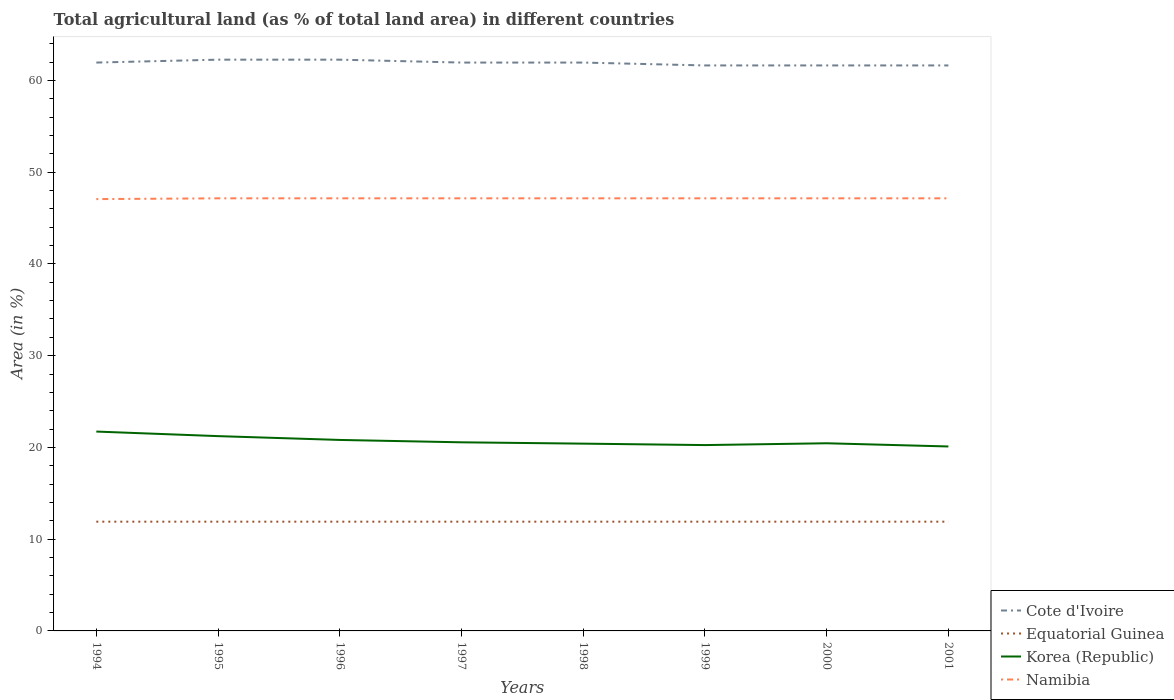How many different coloured lines are there?
Give a very brief answer. 4. Across all years, what is the maximum percentage of agricultural land in Equatorial Guinea?
Your answer should be very brief. 11.91. In which year was the percentage of agricultural land in Namibia maximum?
Keep it short and to the point. 1994. What is the total percentage of agricultural land in Korea (Republic) in the graph?
Give a very brief answer. 0.1. What is the difference between the highest and the second highest percentage of agricultural land in Cote d'Ivoire?
Your response must be concise. 0.63. What is the difference between the highest and the lowest percentage of agricultural land in Namibia?
Offer a very short reply. 7. How many years are there in the graph?
Your answer should be compact. 8. Are the values on the major ticks of Y-axis written in scientific E-notation?
Your answer should be very brief. No. Does the graph contain grids?
Ensure brevity in your answer.  No. Where does the legend appear in the graph?
Provide a succinct answer. Bottom right. How many legend labels are there?
Your answer should be very brief. 4. What is the title of the graph?
Keep it short and to the point. Total agricultural land (as % of total land area) in different countries. What is the label or title of the Y-axis?
Your answer should be very brief. Area (in %). What is the Area (in %) of Cote d'Ivoire in 1994?
Ensure brevity in your answer.  61.95. What is the Area (in %) of Equatorial Guinea in 1994?
Offer a very short reply. 11.91. What is the Area (in %) of Korea (Republic) in 1994?
Make the answer very short. 21.73. What is the Area (in %) of Namibia in 1994?
Keep it short and to the point. 47.07. What is the Area (in %) in Cote d'Ivoire in 1995?
Your answer should be very brief. 62.26. What is the Area (in %) in Equatorial Guinea in 1995?
Provide a succinct answer. 11.91. What is the Area (in %) of Korea (Republic) in 1995?
Provide a short and direct response. 21.23. What is the Area (in %) of Namibia in 1995?
Provide a succinct answer. 47.15. What is the Area (in %) of Cote d'Ivoire in 1996?
Your answer should be very brief. 62.26. What is the Area (in %) in Equatorial Guinea in 1996?
Your answer should be compact. 11.91. What is the Area (in %) in Korea (Republic) in 1996?
Your answer should be very brief. 20.82. What is the Area (in %) in Namibia in 1996?
Provide a succinct answer. 47.15. What is the Area (in %) of Cote d'Ivoire in 1997?
Your answer should be very brief. 61.95. What is the Area (in %) of Equatorial Guinea in 1997?
Ensure brevity in your answer.  11.91. What is the Area (in %) of Korea (Republic) in 1997?
Your answer should be compact. 20.56. What is the Area (in %) of Namibia in 1997?
Keep it short and to the point. 47.15. What is the Area (in %) of Cote d'Ivoire in 1998?
Ensure brevity in your answer.  61.95. What is the Area (in %) of Equatorial Guinea in 1998?
Your response must be concise. 11.91. What is the Area (in %) of Korea (Republic) in 1998?
Provide a succinct answer. 20.41. What is the Area (in %) of Namibia in 1998?
Make the answer very short. 47.15. What is the Area (in %) in Cote d'Ivoire in 1999?
Offer a very short reply. 61.64. What is the Area (in %) of Equatorial Guinea in 1999?
Give a very brief answer. 11.91. What is the Area (in %) of Korea (Republic) in 1999?
Make the answer very short. 20.26. What is the Area (in %) of Namibia in 1999?
Provide a succinct answer. 47.15. What is the Area (in %) of Cote d'Ivoire in 2000?
Offer a terse response. 61.64. What is the Area (in %) of Equatorial Guinea in 2000?
Keep it short and to the point. 11.91. What is the Area (in %) in Korea (Republic) in 2000?
Your answer should be compact. 20.45. What is the Area (in %) in Namibia in 2000?
Keep it short and to the point. 47.15. What is the Area (in %) of Cote d'Ivoire in 2001?
Your answer should be very brief. 61.64. What is the Area (in %) of Equatorial Guinea in 2001?
Provide a succinct answer. 11.91. What is the Area (in %) in Korea (Republic) in 2001?
Offer a very short reply. 20.11. What is the Area (in %) in Namibia in 2001?
Your answer should be very brief. 47.15. Across all years, what is the maximum Area (in %) in Cote d'Ivoire?
Offer a very short reply. 62.26. Across all years, what is the maximum Area (in %) of Equatorial Guinea?
Give a very brief answer. 11.91. Across all years, what is the maximum Area (in %) of Korea (Republic)?
Your answer should be compact. 21.73. Across all years, what is the maximum Area (in %) in Namibia?
Keep it short and to the point. 47.15. Across all years, what is the minimum Area (in %) in Cote d'Ivoire?
Your answer should be compact. 61.64. Across all years, what is the minimum Area (in %) in Equatorial Guinea?
Give a very brief answer. 11.91. Across all years, what is the minimum Area (in %) in Korea (Republic)?
Provide a succinct answer. 20.11. Across all years, what is the minimum Area (in %) in Namibia?
Your answer should be very brief. 47.07. What is the total Area (in %) of Cote d'Ivoire in the graph?
Provide a succinct answer. 495.28. What is the total Area (in %) of Equatorial Guinea in the graph?
Your answer should be very brief. 95.26. What is the total Area (in %) in Korea (Republic) in the graph?
Provide a succinct answer. 165.56. What is the total Area (in %) of Namibia in the graph?
Keep it short and to the point. 377.13. What is the difference between the Area (in %) of Cote d'Ivoire in 1994 and that in 1995?
Offer a terse response. -0.31. What is the difference between the Area (in %) of Equatorial Guinea in 1994 and that in 1995?
Ensure brevity in your answer.  0. What is the difference between the Area (in %) in Korea (Republic) in 1994 and that in 1995?
Provide a short and direct response. 0.5. What is the difference between the Area (in %) of Namibia in 1994 and that in 1995?
Keep it short and to the point. -0.09. What is the difference between the Area (in %) in Cote d'Ivoire in 1994 and that in 1996?
Your answer should be very brief. -0.31. What is the difference between the Area (in %) of Equatorial Guinea in 1994 and that in 1996?
Your response must be concise. 0. What is the difference between the Area (in %) in Korea (Republic) in 1994 and that in 1996?
Provide a succinct answer. 0.91. What is the difference between the Area (in %) of Namibia in 1994 and that in 1996?
Keep it short and to the point. -0.09. What is the difference between the Area (in %) in Equatorial Guinea in 1994 and that in 1997?
Keep it short and to the point. 0. What is the difference between the Area (in %) of Korea (Republic) in 1994 and that in 1997?
Your response must be concise. 1.17. What is the difference between the Area (in %) in Namibia in 1994 and that in 1997?
Provide a succinct answer. -0.09. What is the difference between the Area (in %) in Cote d'Ivoire in 1994 and that in 1998?
Your answer should be compact. 0. What is the difference between the Area (in %) in Equatorial Guinea in 1994 and that in 1998?
Give a very brief answer. 0. What is the difference between the Area (in %) in Korea (Republic) in 1994 and that in 1998?
Provide a succinct answer. 1.32. What is the difference between the Area (in %) in Namibia in 1994 and that in 1998?
Offer a terse response. -0.09. What is the difference between the Area (in %) in Cote d'Ivoire in 1994 and that in 1999?
Your response must be concise. 0.31. What is the difference between the Area (in %) in Korea (Republic) in 1994 and that in 1999?
Give a very brief answer. 1.47. What is the difference between the Area (in %) of Namibia in 1994 and that in 1999?
Make the answer very short. -0.09. What is the difference between the Area (in %) in Cote d'Ivoire in 1994 and that in 2000?
Ensure brevity in your answer.  0.31. What is the difference between the Area (in %) of Equatorial Guinea in 1994 and that in 2000?
Offer a terse response. 0. What is the difference between the Area (in %) in Korea (Republic) in 1994 and that in 2000?
Make the answer very short. 1.28. What is the difference between the Area (in %) of Namibia in 1994 and that in 2000?
Make the answer very short. -0.09. What is the difference between the Area (in %) of Cote d'Ivoire in 1994 and that in 2001?
Offer a terse response. 0.31. What is the difference between the Area (in %) of Korea (Republic) in 1994 and that in 2001?
Keep it short and to the point. 1.62. What is the difference between the Area (in %) of Namibia in 1994 and that in 2001?
Keep it short and to the point. -0.09. What is the difference between the Area (in %) in Cote d'Ivoire in 1995 and that in 1996?
Ensure brevity in your answer.  0. What is the difference between the Area (in %) of Korea (Republic) in 1995 and that in 1996?
Your response must be concise. 0.41. What is the difference between the Area (in %) in Cote d'Ivoire in 1995 and that in 1997?
Your answer should be very brief. 0.31. What is the difference between the Area (in %) of Korea (Republic) in 1995 and that in 1997?
Give a very brief answer. 0.67. What is the difference between the Area (in %) of Namibia in 1995 and that in 1997?
Give a very brief answer. 0. What is the difference between the Area (in %) in Cote d'Ivoire in 1995 and that in 1998?
Offer a very short reply. 0.31. What is the difference between the Area (in %) of Korea (Republic) in 1995 and that in 1998?
Offer a very short reply. 0.82. What is the difference between the Area (in %) of Namibia in 1995 and that in 1998?
Provide a short and direct response. 0. What is the difference between the Area (in %) of Cote d'Ivoire in 1995 and that in 1999?
Your answer should be compact. 0.63. What is the difference between the Area (in %) of Equatorial Guinea in 1995 and that in 1999?
Provide a succinct answer. 0. What is the difference between the Area (in %) in Korea (Republic) in 1995 and that in 1999?
Your response must be concise. 0.97. What is the difference between the Area (in %) in Namibia in 1995 and that in 1999?
Offer a terse response. 0. What is the difference between the Area (in %) in Cote d'Ivoire in 1995 and that in 2000?
Your response must be concise. 0.63. What is the difference between the Area (in %) of Korea (Republic) in 1995 and that in 2000?
Your answer should be compact. 0.78. What is the difference between the Area (in %) in Namibia in 1995 and that in 2000?
Your answer should be compact. 0. What is the difference between the Area (in %) in Cote d'Ivoire in 1995 and that in 2001?
Keep it short and to the point. 0.63. What is the difference between the Area (in %) of Equatorial Guinea in 1995 and that in 2001?
Your response must be concise. 0. What is the difference between the Area (in %) in Korea (Republic) in 1995 and that in 2001?
Provide a succinct answer. 1.13. What is the difference between the Area (in %) in Cote d'Ivoire in 1996 and that in 1997?
Provide a short and direct response. 0.31. What is the difference between the Area (in %) of Korea (Republic) in 1996 and that in 1997?
Offer a very short reply. 0.26. What is the difference between the Area (in %) in Cote d'Ivoire in 1996 and that in 1998?
Your answer should be compact. 0.31. What is the difference between the Area (in %) of Equatorial Guinea in 1996 and that in 1998?
Make the answer very short. 0. What is the difference between the Area (in %) of Korea (Republic) in 1996 and that in 1998?
Provide a short and direct response. 0.4. What is the difference between the Area (in %) in Namibia in 1996 and that in 1998?
Offer a terse response. 0. What is the difference between the Area (in %) of Cote d'Ivoire in 1996 and that in 1999?
Offer a very short reply. 0.63. What is the difference between the Area (in %) of Equatorial Guinea in 1996 and that in 1999?
Provide a succinct answer. 0. What is the difference between the Area (in %) of Korea (Republic) in 1996 and that in 1999?
Your answer should be compact. 0.56. What is the difference between the Area (in %) in Namibia in 1996 and that in 1999?
Your answer should be compact. 0. What is the difference between the Area (in %) in Cote d'Ivoire in 1996 and that in 2000?
Your answer should be compact. 0.63. What is the difference between the Area (in %) in Equatorial Guinea in 1996 and that in 2000?
Ensure brevity in your answer.  0. What is the difference between the Area (in %) in Korea (Republic) in 1996 and that in 2000?
Provide a succinct answer. 0.36. What is the difference between the Area (in %) in Namibia in 1996 and that in 2000?
Your answer should be compact. 0. What is the difference between the Area (in %) in Cote d'Ivoire in 1996 and that in 2001?
Your answer should be compact. 0.63. What is the difference between the Area (in %) in Korea (Republic) in 1996 and that in 2001?
Give a very brief answer. 0.71. What is the difference between the Area (in %) in Namibia in 1996 and that in 2001?
Your answer should be very brief. 0. What is the difference between the Area (in %) of Cote d'Ivoire in 1997 and that in 1998?
Ensure brevity in your answer.  0. What is the difference between the Area (in %) of Korea (Republic) in 1997 and that in 1998?
Offer a very short reply. 0.15. What is the difference between the Area (in %) of Cote d'Ivoire in 1997 and that in 1999?
Your answer should be very brief. 0.31. What is the difference between the Area (in %) of Equatorial Guinea in 1997 and that in 1999?
Provide a succinct answer. 0. What is the difference between the Area (in %) in Korea (Republic) in 1997 and that in 1999?
Provide a short and direct response. 0.3. What is the difference between the Area (in %) in Namibia in 1997 and that in 1999?
Keep it short and to the point. 0. What is the difference between the Area (in %) of Cote d'Ivoire in 1997 and that in 2000?
Make the answer very short. 0.31. What is the difference between the Area (in %) in Korea (Republic) in 1997 and that in 2000?
Keep it short and to the point. 0.1. What is the difference between the Area (in %) of Cote d'Ivoire in 1997 and that in 2001?
Make the answer very short. 0.31. What is the difference between the Area (in %) in Equatorial Guinea in 1997 and that in 2001?
Make the answer very short. 0. What is the difference between the Area (in %) in Korea (Republic) in 1997 and that in 2001?
Give a very brief answer. 0.45. What is the difference between the Area (in %) of Namibia in 1997 and that in 2001?
Your answer should be very brief. 0. What is the difference between the Area (in %) in Cote d'Ivoire in 1998 and that in 1999?
Give a very brief answer. 0.31. What is the difference between the Area (in %) in Equatorial Guinea in 1998 and that in 1999?
Offer a very short reply. 0. What is the difference between the Area (in %) in Korea (Republic) in 1998 and that in 1999?
Offer a very short reply. 0.16. What is the difference between the Area (in %) of Cote d'Ivoire in 1998 and that in 2000?
Your answer should be very brief. 0.31. What is the difference between the Area (in %) of Equatorial Guinea in 1998 and that in 2000?
Offer a terse response. 0. What is the difference between the Area (in %) of Korea (Republic) in 1998 and that in 2000?
Offer a very short reply. -0.04. What is the difference between the Area (in %) of Namibia in 1998 and that in 2000?
Provide a succinct answer. 0. What is the difference between the Area (in %) in Cote d'Ivoire in 1998 and that in 2001?
Your answer should be compact. 0.31. What is the difference between the Area (in %) of Equatorial Guinea in 1998 and that in 2001?
Provide a succinct answer. 0. What is the difference between the Area (in %) in Korea (Republic) in 1998 and that in 2001?
Your answer should be compact. 0.31. What is the difference between the Area (in %) in Cote d'Ivoire in 1999 and that in 2000?
Give a very brief answer. 0. What is the difference between the Area (in %) in Korea (Republic) in 1999 and that in 2000?
Offer a very short reply. -0.2. What is the difference between the Area (in %) of Korea (Republic) in 1999 and that in 2001?
Make the answer very short. 0.15. What is the difference between the Area (in %) of Namibia in 1999 and that in 2001?
Your response must be concise. 0. What is the difference between the Area (in %) in Equatorial Guinea in 2000 and that in 2001?
Your answer should be compact. 0. What is the difference between the Area (in %) of Korea (Republic) in 2000 and that in 2001?
Your answer should be compact. 0.35. What is the difference between the Area (in %) of Namibia in 2000 and that in 2001?
Your answer should be very brief. 0. What is the difference between the Area (in %) of Cote d'Ivoire in 1994 and the Area (in %) of Equatorial Guinea in 1995?
Your answer should be very brief. 50.04. What is the difference between the Area (in %) of Cote d'Ivoire in 1994 and the Area (in %) of Korea (Republic) in 1995?
Make the answer very short. 40.72. What is the difference between the Area (in %) in Cote d'Ivoire in 1994 and the Area (in %) in Namibia in 1995?
Make the answer very short. 14.8. What is the difference between the Area (in %) in Equatorial Guinea in 1994 and the Area (in %) in Korea (Republic) in 1995?
Make the answer very short. -9.32. What is the difference between the Area (in %) in Equatorial Guinea in 1994 and the Area (in %) in Namibia in 1995?
Ensure brevity in your answer.  -35.24. What is the difference between the Area (in %) in Korea (Republic) in 1994 and the Area (in %) in Namibia in 1995?
Provide a short and direct response. -25.42. What is the difference between the Area (in %) of Cote d'Ivoire in 1994 and the Area (in %) of Equatorial Guinea in 1996?
Give a very brief answer. 50.04. What is the difference between the Area (in %) of Cote d'Ivoire in 1994 and the Area (in %) of Korea (Republic) in 1996?
Your answer should be compact. 41.13. What is the difference between the Area (in %) of Cote d'Ivoire in 1994 and the Area (in %) of Namibia in 1996?
Provide a succinct answer. 14.8. What is the difference between the Area (in %) in Equatorial Guinea in 1994 and the Area (in %) in Korea (Republic) in 1996?
Give a very brief answer. -8.91. What is the difference between the Area (in %) of Equatorial Guinea in 1994 and the Area (in %) of Namibia in 1996?
Give a very brief answer. -35.24. What is the difference between the Area (in %) of Korea (Republic) in 1994 and the Area (in %) of Namibia in 1996?
Keep it short and to the point. -25.42. What is the difference between the Area (in %) in Cote d'Ivoire in 1994 and the Area (in %) in Equatorial Guinea in 1997?
Keep it short and to the point. 50.04. What is the difference between the Area (in %) in Cote d'Ivoire in 1994 and the Area (in %) in Korea (Republic) in 1997?
Offer a terse response. 41.39. What is the difference between the Area (in %) in Cote d'Ivoire in 1994 and the Area (in %) in Namibia in 1997?
Your answer should be very brief. 14.8. What is the difference between the Area (in %) in Equatorial Guinea in 1994 and the Area (in %) in Korea (Republic) in 1997?
Your answer should be very brief. -8.65. What is the difference between the Area (in %) of Equatorial Guinea in 1994 and the Area (in %) of Namibia in 1997?
Offer a very short reply. -35.24. What is the difference between the Area (in %) in Korea (Republic) in 1994 and the Area (in %) in Namibia in 1997?
Keep it short and to the point. -25.42. What is the difference between the Area (in %) in Cote d'Ivoire in 1994 and the Area (in %) in Equatorial Guinea in 1998?
Offer a terse response. 50.04. What is the difference between the Area (in %) in Cote d'Ivoire in 1994 and the Area (in %) in Korea (Republic) in 1998?
Provide a short and direct response. 41.54. What is the difference between the Area (in %) in Cote d'Ivoire in 1994 and the Area (in %) in Namibia in 1998?
Your response must be concise. 14.8. What is the difference between the Area (in %) of Equatorial Guinea in 1994 and the Area (in %) of Korea (Republic) in 1998?
Keep it short and to the point. -8.51. What is the difference between the Area (in %) in Equatorial Guinea in 1994 and the Area (in %) in Namibia in 1998?
Offer a terse response. -35.24. What is the difference between the Area (in %) in Korea (Republic) in 1994 and the Area (in %) in Namibia in 1998?
Ensure brevity in your answer.  -25.42. What is the difference between the Area (in %) of Cote d'Ivoire in 1994 and the Area (in %) of Equatorial Guinea in 1999?
Ensure brevity in your answer.  50.04. What is the difference between the Area (in %) in Cote d'Ivoire in 1994 and the Area (in %) in Korea (Republic) in 1999?
Your response must be concise. 41.69. What is the difference between the Area (in %) of Cote d'Ivoire in 1994 and the Area (in %) of Namibia in 1999?
Ensure brevity in your answer.  14.8. What is the difference between the Area (in %) in Equatorial Guinea in 1994 and the Area (in %) in Korea (Republic) in 1999?
Keep it short and to the point. -8.35. What is the difference between the Area (in %) in Equatorial Guinea in 1994 and the Area (in %) in Namibia in 1999?
Your response must be concise. -35.24. What is the difference between the Area (in %) of Korea (Republic) in 1994 and the Area (in %) of Namibia in 1999?
Ensure brevity in your answer.  -25.42. What is the difference between the Area (in %) of Cote d'Ivoire in 1994 and the Area (in %) of Equatorial Guinea in 2000?
Keep it short and to the point. 50.04. What is the difference between the Area (in %) of Cote d'Ivoire in 1994 and the Area (in %) of Korea (Republic) in 2000?
Offer a terse response. 41.5. What is the difference between the Area (in %) in Cote d'Ivoire in 1994 and the Area (in %) in Namibia in 2000?
Provide a succinct answer. 14.8. What is the difference between the Area (in %) in Equatorial Guinea in 1994 and the Area (in %) in Korea (Republic) in 2000?
Offer a terse response. -8.55. What is the difference between the Area (in %) in Equatorial Guinea in 1994 and the Area (in %) in Namibia in 2000?
Provide a short and direct response. -35.24. What is the difference between the Area (in %) in Korea (Republic) in 1994 and the Area (in %) in Namibia in 2000?
Your answer should be compact. -25.42. What is the difference between the Area (in %) in Cote d'Ivoire in 1994 and the Area (in %) in Equatorial Guinea in 2001?
Provide a short and direct response. 50.04. What is the difference between the Area (in %) in Cote d'Ivoire in 1994 and the Area (in %) in Korea (Republic) in 2001?
Ensure brevity in your answer.  41.84. What is the difference between the Area (in %) in Cote d'Ivoire in 1994 and the Area (in %) in Namibia in 2001?
Your response must be concise. 14.8. What is the difference between the Area (in %) in Equatorial Guinea in 1994 and the Area (in %) in Korea (Republic) in 2001?
Offer a terse response. -8.2. What is the difference between the Area (in %) in Equatorial Guinea in 1994 and the Area (in %) in Namibia in 2001?
Your answer should be very brief. -35.24. What is the difference between the Area (in %) in Korea (Republic) in 1994 and the Area (in %) in Namibia in 2001?
Offer a terse response. -25.42. What is the difference between the Area (in %) of Cote d'Ivoire in 1995 and the Area (in %) of Equatorial Guinea in 1996?
Keep it short and to the point. 50.36. What is the difference between the Area (in %) of Cote d'Ivoire in 1995 and the Area (in %) of Korea (Republic) in 1996?
Provide a succinct answer. 41.45. What is the difference between the Area (in %) in Cote d'Ivoire in 1995 and the Area (in %) in Namibia in 1996?
Your answer should be very brief. 15.11. What is the difference between the Area (in %) in Equatorial Guinea in 1995 and the Area (in %) in Korea (Republic) in 1996?
Ensure brevity in your answer.  -8.91. What is the difference between the Area (in %) of Equatorial Guinea in 1995 and the Area (in %) of Namibia in 1996?
Provide a succinct answer. -35.24. What is the difference between the Area (in %) in Korea (Republic) in 1995 and the Area (in %) in Namibia in 1996?
Your answer should be compact. -25.92. What is the difference between the Area (in %) in Cote d'Ivoire in 1995 and the Area (in %) in Equatorial Guinea in 1997?
Make the answer very short. 50.36. What is the difference between the Area (in %) in Cote d'Ivoire in 1995 and the Area (in %) in Korea (Republic) in 1997?
Provide a short and direct response. 41.71. What is the difference between the Area (in %) in Cote d'Ivoire in 1995 and the Area (in %) in Namibia in 1997?
Provide a short and direct response. 15.11. What is the difference between the Area (in %) of Equatorial Guinea in 1995 and the Area (in %) of Korea (Republic) in 1997?
Your answer should be very brief. -8.65. What is the difference between the Area (in %) in Equatorial Guinea in 1995 and the Area (in %) in Namibia in 1997?
Your answer should be compact. -35.24. What is the difference between the Area (in %) of Korea (Republic) in 1995 and the Area (in %) of Namibia in 1997?
Provide a short and direct response. -25.92. What is the difference between the Area (in %) in Cote d'Ivoire in 1995 and the Area (in %) in Equatorial Guinea in 1998?
Your answer should be compact. 50.36. What is the difference between the Area (in %) of Cote d'Ivoire in 1995 and the Area (in %) of Korea (Republic) in 1998?
Your answer should be compact. 41.85. What is the difference between the Area (in %) of Cote d'Ivoire in 1995 and the Area (in %) of Namibia in 1998?
Provide a short and direct response. 15.11. What is the difference between the Area (in %) in Equatorial Guinea in 1995 and the Area (in %) in Korea (Republic) in 1998?
Offer a very short reply. -8.51. What is the difference between the Area (in %) in Equatorial Guinea in 1995 and the Area (in %) in Namibia in 1998?
Your answer should be compact. -35.24. What is the difference between the Area (in %) of Korea (Republic) in 1995 and the Area (in %) of Namibia in 1998?
Keep it short and to the point. -25.92. What is the difference between the Area (in %) in Cote d'Ivoire in 1995 and the Area (in %) in Equatorial Guinea in 1999?
Make the answer very short. 50.36. What is the difference between the Area (in %) of Cote d'Ivoire in 1995 and the Area (in %) of Korea (Republic) in 1999?
Give a very brief answer. 42.01. What is the difference between the Area (in %) of Cote d'Ivoire in 1995 and the Area (in %) of Namibia in 1999?
Your answer should be compact. 15.11. What is the difference between the Area (in %) of Equatorial Guinea in 1995 and the Area (in %) of Korea (Republic) in 1999?
Offer a very short reply. -8.35. What is the difference between the Area (in %) of Equatorial Guinea in 1995 and the Area (in %) of Namibia in 1999?
Your response must be concise. -35.24. What is the difference between the Area (in %) of Korea (Republic) in 1995 and the Area (in %) of Namibia in 1999?
Ensure brevity in your answer.  -25.92. What is the difference between the Area (in %) of Cote d'Ivoire in 1995 and the Area (in %) of Equatorial Guinea in 2000?
Ensure brevity in your answer.  50.36. What is the difference between the Area (in %) in Cote d'Ivoire in 1995 and the Area (in %) in Korea (Republic) in 2000?
Make the answer very short. 41.81. What is the difference between the Area (in %) in Cote d'Ivoire in 1995 and the Area (in %) in Namibia in 2000?
Your response must be concise. 15.11. What is the difference between the Area (in %) in Equatorial Guinea in 1995 and the Area (in %) in Korea (Republic) in 2000?
Give a very brief answer. -8.55. What is the difference between the Area (in %) of Equatorial Guinea in 1995 and the Area (in %) of Namibia in 2000?
Keep it short and to the point. -35.24. What is the difference between the Area (in %) in Korea (Republic) in 1995 and the Area (in %) in Namibia in 2000?
Provide a short and direct response. -25.92. What is the difference between the Area (in %) of Cote d'Ivoire in 1995 and the Area (in %) of Equatorial Guinea in 2001?
Offer a very short reply. 50.36. What is the difference between the Area (in %) in Cote d'Ivoire in 1995 and the Area (in %) in Korea (Republic) in 2001?
Your response must be concise. 42.16. What is the difference between the Area (in %) in Cote d'Ivoire in 1995 and the Area (in %) in Namibia in 2001?
Provide a short and direct response. 15.11. What is the difference between the Area (in %) of Equatorial Guinea in 1995 and the Area (in %) of Korea (Republic) in 2001?
Your answer should be very brief. -8.2. What is the difference between the Area (in %) of Equatorial Guinea in 1995 and the Area (in %) of Namibia in 2001?
Your answer should be very brief. -35.24. What is the difference between the Area (in %) of Korea (Republic) in 1995 and the Area (in %) of Namibia in 2001?
Offer a terse response. -25.92. What is the difference between the Area (in %) of Cote d'Ivoire in 1996 and the Area (in %) of Equatorial Guinea in 1997?
Provide a succinct answer. 50.36. What is the difference between the Area (in %) in Cote d'Ivoire in 1996 and the Area (in %) in Korea (Republic) in 1997?
Keep it short and to the point. 41.71. What is the difference between the Area (in %) in Cote d'Ivoire in 1996 and the Area (in %) in Namibia in 1997?
Provide a short and direct response. 15.11. What is the difference between the Area (in %) in Equatorial Guinea in 1996 and the Area (in %) in Korea (Republic) in 1997?
Provide a succinct answer. -8.65. What is the difference between the Area (in %) of Equatorial Guinea in 1996 and the Area (in %) of Namibia in 1997?
Provide a succinct answer. -35.24. What is the difference between the Area (in %) in Korea (Republic) in 1996 and the Area (in %) in Namibia in 1997?
Provide a succinct answer. -26.34. What is the difference between the Area (in %) in Cote d'Ivoire in 1996 and the Area (in %) in Equatorial Guinea in 1998?
Give a very brief answer. 50.36. What is the difference between the Area (in %) in Cote d'Ivoire in 1996 and the Area (in %) in Korea (Republic) in 1998?
Your response must be concise. 41.85. What is the difference between the Area (in %) of Cote d'Ivoire in 1996 and the Area (in %) of Namibia in 1998?
Your response must be concise. 15.11. What is the difference between the Area (in %) in Equatorial Guinea in 1996 and the Area (in %) in Korea (Republic) in 1998?
Your answer should be very brief. -8.51. What is the difference between the Area (in %) of Equatorial Guinea in 1996 and the Area (in %) of Namibia in 1998?
Make the answer very short. -35.24. What is the difference between the Area (in %) in Korea (Republic) in 1996 and the Area (in %) in Namibia in 1998?
Keep it short and to the point. -26.34. What is the difference between the Area (in %) in Cote d'Ivoire in 1996 and the Area (in %) in Equatorial Guinea in 1999?
Offer a terse response. 50.36. What is the difference between the Area (in %) in Cote d'Ivoire in 1996 and the Area (in %) in Korea (Republic) in 1999?
Offer a very short reply. 42.01. What is the difference between the Area (in %) in Cote d'Ivoire in 1996 and the Area (in %) in Namibia in 1999?
Provide a succinct answer. 15.11. What is the difference between the Area (in %) in Equatorial Guinea in 1996 and the Area (in %) in Korea (Republic) in 1999?
Provide a short and direct response. -8.35. What is the difference between the Area (in %) of Equatorial Guinea in 1996 and the Area (in %) of Namibia in 1999?
Provide a short and direct response. -35.24. What is the difference between the Area (in %) of Korea (Republic) in 1996 and the Area (in %) of Namibia in 1999?
Ensure brevity in your answer.  -26.34. What is the difference between the Area (in %) in Cote d'Ivoire in 1996 and the Area (in %) in Equatorial Guinea in 2000?
Provide a succinct answer. 50.36. What is the difference between the Area (in %) of Cote d'Ivoire in 1996 and the Area (in %) of Korea (Republic) in 2000?
Offer a terse response. 41.81. What is the difference between the Area (in %) of Cote d'Ivoire in 1996 and the Area (in %) of Namibia in 2000?
Offer a very short reply. 15.11. What is the difference between the Area (in %) in Equatorial Guinea in 1996 and the Area (in %) in Korea (Republic) in 2000?
Your answer should be very brief. -8.55. What is the difference between the Area (in %) in Equatorial Guinea in 1996 and the Area (in %) in Namibia in 2000?
Keep it short and to the point. -35.24. What is the difference between the Area (in %) of Korea (Republic) in 1996 and the Area (in %) of Namibia in 2000?
Your answer should be very brief. -26.34. What is the difference between the Area (in %) of Cote d'Ivoire in 1996 and the Area (in %) of Equatorial Guinea in 2001?
Provide a short and direct response. 50.36. What is the difference between the Area (in %) in Cote d'Ivoire in 1996 and the Area (in %) in Korea (Republic) in 2001?
Your response must be concise. 42.16. What is the difference between the Area (in %) in Cote d'Ivoire in 1996 and the Area (in %) in Namibia in 2001?
Offer a very short reply. 15.11. What is the difference between the Area (in %) in Equatorial Guinea in 1996 and the Area (in %) in Korea (Republic) in 2001?
Provide a succinct answer. -8.2. What is the difference between the Area (in %) of Equatorial Guinea in 1996 and the Area (in %) of Namibia in 2001?
Make the answer very short. -35.24. What is the difference between the Area (in %) in Korea (Republic) in 1996 and the Area (in %) in Namibia in 2001?
Your answer should be compact. -26.34. What is the difference between the Area (in %) in Cote d'Ivoire in 1997 and the Area (in %) in Equatorial Guinea in 1998?
Your answer should be very brief. 50.04. What is the difference between the Area (in %) of Cote d'Ivoire in 1997 and the Area (in %) of Korea (Republic) in 1998?
Offer a very short reply. 41.54. What is the difference between the Area (in %) of Cote d'Ivoire in 1997 and the Area (in %) of Namibia in 1998?
Provide a short and direct response. 14.8. What is the difference between the Area (in %) in Equatorial Guinea in 1997 and the Area (in %) in Korea (Republic) in 1998?
Keep it short and to the point. -8.51. What is the difference between the Area (in %) in Equatorial Guinea in 1997 and the Area (in %) in Namibia in 1998?
Offer a terse response. -35.24. What is the difference between the Area (in %) of Korea (Republic) in 1997 and the Area (in %) of Namibia in 1998?
Give a very brief answer. -26.59. What is the difference between the Area (in %) of Cote d'Ivoire in 1997 and the Area (in %) of Equatorial Guinea in 1999?
Your answer should be very brief. 50.04. What is the difference between the Area (in %) in Cote d'Ivoire in 1997 and the Area (in %) in Korea (Republic) in 1999?
Give a very brief answer. 41.69. What is the difference between the Area (in %) in Cote d'Ivoire in 1997 and the Area (in %) in Namibia in 1999?
Provide a short and direct response. 14.8. What is the difference between the Area (in %) in Equatorial Guinea in 1997 and the Area (in %) in Korea (Republic) in 1999?
Provide a short and direct response. -8.35. What is the difference between the Area (in %) of Equatorial Guinea in 1997 and the Area (in %) of Namibia in 1999?
Make the answer very short. -35.24. What is the difference between the Area (in %) in Korea (Republic) in 1997 and the Area (in %) in Namibia in 1999?
Make the answer very short. -26.59. What is the difference between the Area (in %) of Cote d'Ivoire in 1997 and the Area (in %) of Equatorial Guinea in 2000?
Make the answer very short. 50.04. What is the difference between the Area (in %) of Cote d'Ivoire in 1997 and the Area (in %) of Korea (Republic) in 2000?
Make the answer very short. 41.5. What is the difference between the Area (in %) of Cote d'Ivoire in 1997 and the Area (in %) of Namibia in 2000?
Give a very brief answer. 14.8. What is the difference between the Area (in %) of Equatorial Guinea in 1997 and the Area (in %) of Korea (Republic) in 2000?
Keep it short and to the point. -8.55. What is the difference between the Area (in %) of Equatorial Guinea in 1997 and the Area (in %) of Namibia in 2000?
Your response must be concise. -35.24. What is the difference between the Area (in %) of Korea (Republic) in 1997 and the Area (in %) of Namibia in 2000?
Keep it short and to the point. -26.59. What is the difference between the Area (in %) of Cote d'Ivoire in 1997 and the Area (in %) of Equatorial Guinea in 2001?
Your answer should be compact. 50.04. What is the difference between the Area (in %) of Cote d'Ivoire in 1997 and the Area (in %) of Korea (Republic) in 2001?
Provide a succinct answer. 41.84. What is the difference between the Area (in %) in Cote d'Ivoire in 1997 and the Area (in %) in Namibia in 2001?
Offer a terse response. 14.8. What is the difference between the Area (in %) of Equatorial Guinea in 1997 and the Area (in %) of Korea (Republic) in 2001?
Keep it short and to the point. -8.2. What is the difference between the Area (in %) in Equatorial Guinea in 1997 and the Area (in %) in Namibia in 2001?
Give a very brief answer. -35.24. What is the difference between the Area (in %) in Korea (Republic) in 1997 and the Area (in %) in Namibia in 2001?
Give a very brief answer. -26.59. What is the difference between the Area (in %) of Cote d'Ivoire in 1998 and the Area (in %) of Equatorial Guinea in 1999?
Your response must be concise. 50.04. What is the difference between the Area (in %) of Cote d'Ivoire in 1998 and the Area (in %) of Korea (Republic) in 1999?
Offer a terse response. 41.69. What is the difference between the Area (in %) of Cote d'Ivoire in 1998 and the Area (in %) of Namibia in 1999?
Offer a very short reply. 14.8. What is the difference between the Area (in %) of Equatorial Guinea in 1998 and the Area (in %) of Korea (Republic) in 1999?
Offer a terse response. -8.35. What is the difference between the Area (in %) in Equatorial Guinea in 1998 and the Area (in %) in Namibia in 1999?
Ensure brevity in your answer.  -35.24. What is the difference between the Area (in %) in Korea (Republic) in 1998 and the Area (in %) in Namibia in 1999?
Your response must be concise. -26.74. What is the difference between the Area (in %) in Cote d'Ivoire in 1998 and the Area (in %) in Equatorial Guinea in 2000?
Provide a succinct answer. 50.04. What is the difference between the Area (in %) of Cote d'Ivoire in 1998 and the Area (in %) of Korea (Republic) in 2000?
Keep it short and to the point. 41.5. What is the difference between the Area (in %) of Cote d'Ivoire in 1998 and the Area (in %) of Namibia in 2000?
Provide a short and direct response. 14.8. What is the difference between the Area (in %) in Equatorial Guinea in 1998 and the Area (in %) in Korea (Republic) in 2000?
Your answer should be compact. -8.55. What is the difference between the Area (in %) of Equatorial Guinea in 1998 and the Area (in %) of Namibia in 2000?
Your answer should be very brief. -35.24. What is the difference between the Area (in %) of Korea (Republic) in 1998 and the Area (in %) of Namibia in 2000?
Keep it short and to the point. -26.74. What is the difference between the Area (in %) in Cote d'Ivoire in 1998 and the Area (in %) in Equatorial Guinea in 2001?
Your response must be concise. 50.04. What is the difference between the Area (in %) of Cote d'Ivoire in 1998 and the Area (in %) of Korea (Republic) in 2001?
Your response must be concise. 41.84. What is the difference between the Area (in %) of Cote d'Ivoire in 1998 and the Area (in %) of Namibia in 2001?
Ensure brevity in your answer.  14.8. What is the difference between the Area (in %) in Equatorial Guinea in 1998 and the Area (in %) in Korea (Republic) in 2001?
Provide a short and direct response. -8.2. What is the difference between the Area (in %) of Equatorial Guinea in 1998 and the Area (in %) of Namibia in 2001?
Give a very brief answer. -35.24. What is the difference between the Area (in %) in Korea (Republic) in 1998 and the Area (in %) in Namibia in 2001?
Give a very brief answer. -26.74. What is the difference between the Area (in %) in Cote d'Ivoire in 1999 and the Area (in %) in Equatorial Guinea in 2000?
Ensure brevity in your answer.  49.73. What is the difference between the Area (in %) of Cote d'Ivoire in 1999 and the Area (in %) of Korea (Republic) in 2000?
Make the answer very short. 41.18. What is the difference between the Area (in %) of Cote d'Ivoire in 1999 and the Area (in %) of Namibia in 2000?
Offer a terse response. 14.48. What is the difference between the Area (in %) of Equatorial Guinea in 1999 and the Area (in %) of Korea (Republic) in 2000?
Give a very brief answer. -8.55. What is the difference between the Area (in %) in Equatorial Guinea in 1999 and the Area (in %) in Namibia in 2000?
Make the answer very short. -35.24. What is the difference between the Area (in %) in Korea (Republic) in 1999 and the Area (in %) in Namibia in 2000?
Keep it short and to the point. -26.9. What is the difference between the Area (in %) of Cote d'Ivoire in 1999 and the Area (in %) of Equatorial Guinea in 2001?
Your answer should be very brief. 49.73. What is the difference between the Area (in %) in Cote d'Ivoire in 1999 and the Area (in %) in Korea (Republic) in 2001?
Make the answer very short. 41.53. What is the difference between the Area (in %) of Cote d'Ivoire in 1999 and the Area (in %) of Namibia in 2001?
Provide a short and direct response. 14.48. What is the difference between the Area (in %) in Equatorial Guinea in 1999 and the Area (in %) in Korea (Republic) in 2001?
Give a very brief answer. -8.2. What is the difference between the Area (in %) in Equatorial Guinea in 1999 and the Area (in %) in Namibia in 2001?
Keep it short and to the point. -35.24. What is the difference between the Area (in %) in Korea (Republic) in 1999 and the Area (in %) in Namibia in 2001?
Make the answer very short. -26.9. What is the difference between the Area (in %) in Cote d'Ivoire in 2000 and the Area (in %) in Equatorial Guinea in 2001?
Your response must be concise. 49.73. What is the difference between the Area (in %) in Cote d'Ivoire in 2000 and the Area (in %) in Korea (Republic) in 2001?
Give a very brief answer. 41.53. What is the difference between the Area (in %) in Cote d'Ivoire in 2000 and the Area (in %) in Namibia in 2001?
Ensure brevity in your answer.  14.48. What is the difference between the Area (in %) in Equatorial Guinea in 2000 and the Area (in %) in Korea (Republic) in 2001?
Your answer should be compact. -8.2. What is the difference between the Area (in %) of Equatorial Guinea in 2000 and the Area (in %) of Namibia in 2001?
Provide a succinct answer. -35.24. What is the difference between the Area (in %) of Korea (Republic) in 2000 and the Area (in %) of Namibia in 2001?
Provide a short and direct response. -26.7. What is the average Area (in %) in Cote d'Ivoire per year?
Your response must be concise. 61.91. What is the average Area (in %) in Equatorial Guinea per year?
Provide a short and direct response. 11.91. What is the average Area (in %) in Korea (Republic) per year?
Your response must be concise. 20.7. What is the average Area (in %) in Namibia per year?
Keep it short and to the point. 47.14. In the year 1994, what is the difference between the Area (in %) of Cote d'Ivoire and Area (in %) of Equatorial Guinea?
Offer a very short reply. 50.04. In the year 1994, what is the difference between the Area (in %) in Cote d'Ivoire and Area (in %) in Korea (Republic)?
Your answer should be very brief. 40.22. In the year 1994, what is the difference between the Area (in %) in Cote d'Ivoire and Area (in %) in Namibia?
Make the answer very short. 14.88. In the year 1994, what is the difference between the Area (in %) in Equatorial Guinea and Area (in %) in Korea (Republic)?
Offer a very short reply. -9.82. In the year 1994, what is the difference between the Area (in %) of Equatorial Guinea and Area (in %) of Namibia?
Your answer should be very brief. -35.16. In the year 1994, what is the difference between the Area (in %) of Korea (Republic) and Area (in %) of Namibia?
Keep it short and to the point. -25.34. In the year 1995, what is the difference between the Area (in %) in Cote d'Ivoire and Area (in %) in Equatorial Guinea?
Your answer should be compact. 50.36. In the year 1995, what is the difference between the Area (in %) of Cote d'Ivoire and Area (in %) of Korea (Republic)?
Offer a very short reply. 41.03. In the year 1995, what is the difference between the Area (in %) of Cote d'Ivoire and Area (in %) of Namibia?
Your response must be concise. 15.11. In the year 1995, what is the difference between the Area (in %) in Equatorial Guinea and Area (in %) in Korea (Republic)?
Offer a very short reply. -9.32. In the year 1995, what is the difference between the Area (in %) of Equatorial Guinea and Area (in %) of Namibia?
Provide a succinct answer. -35.24. In the year 1995, what is the difference between the Area (in %) in Korea (Republic) and Area (in %) in Namibia?
Your answer should be compact. -25.92. In the year 1996, what is the difference between the Area (in %) of Cote d'Ivoire and Area (in %) of Equatorial Guinea?
Make the answer very short. 50.36. In the year 1996, what is the difference between the Area (in %) of Cote d'Ivoire and Area (in %) of Korea (Republic)?
Offer a terse response. 41.45. In the year 1996, what is the difference between the Area (in %) of Cote d'Ivoire and Area (in %) of Namibia?
Offer a very short reply. 15.11. In the year 1996, what is the difference between the Area (in %) in Equatorial Guinea and Area (in %) in Korea (Republic)?
Give a very brief answer. -8.91. In the year 1996, what is the difference between the Area (in %) in Equatorial Guinea and Area (in %) in Namibia?
Keep it short and to the point. -35.24. In the year 1996, what is the difference between the Area (in %) in Korea (Republic) and Area (in %) in Namibia?
Provide a short and direct response. -26.34. In the year 1997, what is the difference between the Area (in %) in Cote d'Ivoire and Area (in %) in Equatorial Guinea?
Provide a succinct answer. 50.04. In the year 1997, what is the difference between the Area (in %) of Cote d'Ivoire and Area (in %) of Korea (Republic)?
Your answer should be compact. 41.39. In the year 1997, what is the difference between the Area (in %) of Cote d'Ivoire and Area (in %) of Namibia?
Provide a succinct answer. 14.8. In the year 1997, what is the difference between the Area (in %) in Equatorial Guinea and Area (in %) in Korea (Republic)?
Give a very brief answer. -8.65. In the year 1997, what is the difference between the Area (in %) of Equatorial Guinea and Area (in %) of Namibia?
Your response must be concise. -35.24. In the year 1997, what is the difference between the Area (in %) of Korea (Republic) and Area (in %) of Namibia?
Provide a succinct answer. -26.59. In the year 1998, what is the difference between the Area (in %) of Cote d'Ivoire and Area (in %) of Equatorial Guinea?
Provide a succinct answer. 50.04. In the year 1998, what is the difference between the Area (in %) in Cote d'Ivoire and Area (in %) in Korea (Republic)?
Keep it short and to the point. 41.54. In the year 1998, what is the difference between the Area (in %) of Cote d'Ivoire and Area (in %) of Namibia?
Ensure brevity in your answer.  14.8. In the year 1998, what is the difference between the Area (in %) of Equatorial Guinea and Area (in %) of Korea (Republic)?
Ensure brevity in your answer.  -8.51. In the year 1998, what is the difference between the Area (in %) of Equatorial Guinea and Area (in %) of Namibia?
Provide a short and direct response. -35.24. In the year 1998, what is the difference between the Area (in %) in Korea (Republic) and Area (in %) in Namibia?
Your answer should be compact. -26.74. In the year 1999, what is the difference between the Area (in %) of Cote d'Ivoire and Area (in %) of Equatorial Guinea?
Ensure brevity in your answer.  49.73. In the year 1999, what is the difference between the Area (in %) of Cote d'Ivoire and Area (in %) of Korea (Republic)?
Your answer should be very brief. 41.38. In the year 1999, what is the difference between the Area (in %) of Cote d'Ivoire and Area (in %) of Namibia?
Make the answer very short. 14.48. In the year 1999, what is the difference between the Area (in %) in Equatorial Guinea and Area (in %) in Korea (Republic)?
Offer a very short reply. -8.35. In the year 1999, what is the difference between the Area (in %) in Equatorial Guinea and Area (in %) in Namibia?
Your response must be concise. -35.24. In the year 1999, what is the difference between the Area (in %) of Korea (Republic) and Area (in %) of Namibia?
Your answer should be very brief. -26.9. In the year 2000, what is the difference between the Area (in %) of Cote d'Ivoire and Area (in %) of Equatorial Guinea?
Your answer should be very brief. 49.73. In the year 2000, what is the difference between the Area (in %) in Cote d'Ivoire and Area (in %) in Korea (Republic)?
Give a very brief answer. 41.18. In the year 2000, what is the difference between the Area (in %) of Cote d'Ivoire and Area (in %) of Namibia?
Your answer should be very brief. 14.48. In the year 2000, what is the difference between the Area (in %) in Equatorial Guinea and Area (in %) in Korea (Republic)?
Offer a very short reply. -8.55. In the year 2000, what is the difference between the Area (in %) in Equatorial Guinea and Area (in %) in Namibia?
Keep it short and to the point. -35.24. In the year 2000, what is the difference between the Area (in %) of Korea (Republic) and Area (in %) of Namibia?
Your response must be concise. -26.7. In the year 2001, what is the difference between the Area (in %) of Cote d'Ivoire and Area (in %) of Equatorial Guinea?
Your response must be concise. 49.73. In the year 2001, what is the difference between the Area (in %) of Cote d'Ivoire and Area (in %) of Korea (Republic)?
Provide a short and direct response. 41.53. In the year 2001, what is the difference between the Area (in %) in Cote d'Ivoire and Area (in %) in Namibia?
Your answer should be very brief. 14.48. In the year 2001, what is the difference between the Area (in %) in Equatorial Guinea and Area (in %) in Korea (Republic)?
Your answer should be compact. -8.2. In the year 2001, what is the difference between the Area (in %) in Equatorial Guinea and Area (in %) in Namibia?
Your answer should be compact. -35.24. In the year 2001, what is the difference between the Area (in %) in Korea (Republic) and Area (in %) in Namibia?
Provide a succinct answer. -27.05. What is the ratio of the Area (in %) of Cote d'Ivoire in 1994 to that in 1995?
Offer a terse response. 0.99. What is the ratio of the Area (in %) in Equatorial Guinea in 1994 to that in 1995?
Ensure brevity in your answer.  1. What is the ratio of the Area (in %) in Korea (Republic) in 1994 to that in 1995?
Your answer should be very brief. 1.02. What is the ratio of the Area (in %) of Namibia in 1994 to that in 1995?
Offer a very short reply. 1. What is the ratio of the Area (in %) of Cote d'Ivoire in 1994 to that in 1996?
Your response must be concise. 0.99. What is the ratio of the Area (in %) of Korea (Republic) in 1994 to that in 1996?
Keep it short and to the point. 1.04. What is the ratio of the Area (in %) in Namibia in 1994 to that in 1996?
Give a very brief answer. 1. What is the ratio of the Area (in %) of Korea (Republic) in 1994 to that in 1997?
Offer a very short reply. 1.06. What is the ratio of the Area (in %) of Namibia in 1994 to that in 1997?
Provide a succinct answer. 1. What is the ratio of the Area (in %) of Cote d'Ivoire in 1994 to that in 1998?
Give a very brief answer. 1. What is the ratio of the Area (in %) of Korea (Republic) in 1994 to that in 1998?
Provide a short and direct response. 1.06. What is the ratio of the Area (in %) in Cote d'Ivoire in 1994 to that in 1999?
Your answer should be very brief. 1.01. What is the ratio of the Area (in %) of Equatorial Guinea in 1994 to that in 1999?
Keep it short and to the point. 1. What is the ratio of the Area (in %) of Korea (Republic) in 1994 to that in 1999?
Keep it short and to the point. 1.07. What is the ratio of the Area (in %) in Namibia in 1994 to that in 1999?
Offer a terse response. 1. What is the ratio of the Area (in %) in Cote d'Ivoire in 1994 to that in 2000?
Offer a very short reply. 1.01. What is the ratio of the Area (in %) of Korea (Republic) in 1994 to that in 2000?
Keep it short and to the point. 1.06. What is the ratio of the Area (in %) in Namibia in 1994 to that in 2000?
Keep it short and to the point. 1. What is the ratio of the Area (in %) of Korea (Republic) in 1994 to that in 2001?
Ensure brevity in your answer.  1.08. What is the ratio of the Area (in %) of Namibia in 1994 to that in 2001?
Your response must be concise. 1. What is the ratio of the Area (in %) of Equatorial Guinea in 1995 to that in 1996?
Ensure brevity in your answer.  1. What is the ratio of the Area (in %) in Korea (Republic) in 1995 to that in 1996?
Provide a short and direct response. 1.02. What is the ratio of the Area (in %) in Korea (Republic) in 1995 to that in 1997?
Offer a very short reply. 1.03. What is the ratio of the Area (in %) of Cote d'Ivoire in 1995 to that in 1998?
Ensure brevity in your answer.  1.01. What is the ratio of the Area (in %) of Equatorial Guinea in 1995 to that in 1998?
Provide a short and direct response. 1. What is the ratio of the Area (in %) in Korea (Republic) in 1995 to that in 1998?
Offer a very short reply. 1.04. What is the ratio of the Area (in %) in Namibia in 1995 to that in 1998?
Offer a very short reply. 1. What is the ratio of the Area (in %) of Cote d'Ivoire in 1995 to that in 1999?
Provide a short and direct response. 1.01. What is the ratio of the Area (in %) of Equatorial Guinea in 1995 to that in 1999?
Offer a very short reply. 1. What is the ratio of the Area (in %) in Korea (Republic) in 1995 to that in 1999?
Provide a succinct answer. 1.05. What is the ratio of the Area (in %) in Namibia in 1995 to that in 1999?
Make the answer very short. 1. What is the ratio of the Area (in %) of Cote d'Ivoire in 1995 to that in 2000?
Keep it short and to the point. 1.01. What is the ratio of the Area (in %) of Korea (Republic) in 1995 to that in 2000?
Provide a succinct answer. 1.04. What is the ratio of the Area (in %) of Namibia in 1995 to that in 2000?
Your answer should be very brief. 1. What is the ratio of the Area (in %) of Cote d'Ivoire in 1995 to that in 2001?
Give a very brief answer. 1.01. What is the ratio of the Area (in %) of Equatorial Guinea in 1995 to that in 2001?
Provide a succinct answer. 1. What is the ratio of the Area (in %) in Korea (Republic) in 1995 to that in 2001?
Offer a terse response. 1.06. What is the ratio of the Area (in %) of Namibia in 1995 to that in 2001?
Offer a very short reply. 1. What is the ratio of the Area (in %) of Cote d'Ivoire in 1996 to that in 1997?
Your answer should be compact. 1.01. What is the ratio of the Area (in %) in Korea (Republic) in 1996 to that in 1997?
Make the answer very short. 1.01. What is the ratio of the Area (in %) of Equatorial Guinea in 1996 to that in 1998?
Your answer should be very brief. 1. What is the ratio of the Area (in %) of Korea (Republic) in 1996 to that in 1998?
Make the answer very short. 1.02. What is the ratio of the Area (in %) of Namibia in 1996 to that in 1998?
Offer a very short reply. 1. What is the ratio of the Area (in %) of Cote d'Ivoire in 1996 to that in 1999?
Offer a very short reply. 1.01. What is the ratio of the Area (in %) in Korea (Republic) in 1996 to that in 1999?
Your answer should be compact. 1.03. What is the ratio of the Area (in %) in Namibia in 1996 to that in 1999?
Offer a very short reply. 1. What is the ratio of the Area (in %) in Cote d'Ivoire in 1996 to that in 2000?
Provide a short and direct response. 1.01. What is the ratio of the Area (in %) in Equatorial Guinea in 1996 to that in 2000?
Give a very brief answer. 1. What is the ratio of the Area (in %) of Korea (Republic) in 1996 to that in 2000?
Keep it short and to the point. 1.02. What is the ratio of the Area (in %) in Namibia in 1996 to that in 2000?
Your answer should be very brief. 1. What is the ratio of the Area (in %) of Cote d'Ivoire in 1996 to that in 2001?
Offer a very short reply. 1.01. What is the ratio of the Area (in %) in Equatorial Guinea in 1996 to that in 2001?
Provide a short and direct response. 1. What is the ratio of the Area (in %) of Korea (Republic) in 1996 to that in 2001?
Offer a terse response. 1.04. What is the ratio of the Area (in %) in Namibia in 1996 to that in 2001?
Ensure brevity in your answer.  1. What is the ratio of the Area (in %) of Cote d'Ivoire in 1997 to that in 1998?
Keep it short and to the point. 1. What is the ratio of the Area (in %) of Equatorial Guinea in 1997 to that in 1998?
Keep it short and to the point. 1. What is the ratio of the Area (in %) of Korea (Republic) in 1997 to that in 1998?
Keep it short and to the point. 1.01. What is the ratio of the Area (in %) of Namibia in 1997 to that in 1998?
Keep it short and to the point. 1. What is the ratio of the Area (in %) in Korea (Republic) in 1997 to that in 1999?
Make the answer very short. 1.01. What is the ratio of the Area (in %) of Namibia in 1997 to that in 1999?
Ensure brevity in your answer.  1. What is the ratio of the Area (in %) in Cote d'Ivoire in 1997 to that in 2000?
Ensure brevity in your answer.  1.01. What is the ratio of the Area (in %) of Korea (Republic) in 1997 to that in 2000?
Provide a succinct answer. 1.01. What is the ratio of the Area (in %) of Namibia in 1997 to that in 2000?
Offer a very short reply. 1. What is the ratio of the Area (in %) of Korea (Republic) in 1997 to that in 2001?
Your response must be concise. 1.02. What is the ratio of the Area (in %) of Equatorial Guinea in 1998 to that in 1999?
Ensure brevity in your answer.  1. What is the ratio of the Area (in %) of Korea (Republic) in 1998 to that in 1999?
Make the answer very short. 1.01. What is the ratio of the Area (in %) in Cote d'Ivoire in 1998 to that in 2000?
Ensure brevity in your answer.  1.01. What is the ratio of the Area (in %) of Equatorial Guinea in 1998 to that in 2000?
Provide a succinct answer. 1. What is the ratio of the Area (in %) of Namibia in 1998 to that in 2000?
Provide a short and direct response. 1. What is the ratio of the Area (in %) in Korea (Republic) in 1998 to that in 2001?
Offer a very short reply. 1.02. What is the ratio of the Area (in %) in Namibia in 1998 to that in 2001?
Ensure brevity in your answer.  1. What is the ratio of the Area (in %) in Korea (Republic) in 1999 to that in 2000?
Provide a short and direct response. 0.99. What is the ratio of the Area (in %) in Namibia in 1999 to that in 2000?
Provide a short and direct response. 1. What is the ratio of the Area (in %) in Equatorial Guinea in 1999 to that in 2001?
Your response must be concise. 1. What is the ratio of the Area (in %) of Korea (Republic) in 1999 to that in 2001?
Give a very brief answer. 1.01. What is the ratio of the Area (in %) of Korea (Republic) in 2000 to that in 2001?
Your answer should be compact. 1.02. What is the ratio of the Area (in %) of Namibia in 2000 to that in 2001?
Provide a succinct answer. 1. What is the difference between the highest and the second highest Area (in %) of Cote d'Ivoire?
Your response must be concise. 0. What is the difference between the highest and the second highest Area (in %) in Equatorial Guinea?
Your answer should be very brief. 0. What is the difference between the highest and the second highest Area (in %) in Korea (Republic)?
Offer a very short reply. 0.5. What is the difference between the highest and the lowest Area (in %) in Cote d'Ivoire?
Your answer should be compact. 0.63. What is the difference between the highest and the lowest Area (in %) of Equatorial Guinea?
Ensure brevity in your answer.  0. What is the difference between the highest and the lowest Area (in %) of Korea (Republic)?
Your answer should be compact. 1.62. What is the difference between the highest and the lowest Area (in %) in Namibia?
Offer a terse response. 0.09. 